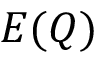<formula> <loc_0><loc_0><loc_500><loc_500>E ( Q )</formula> 